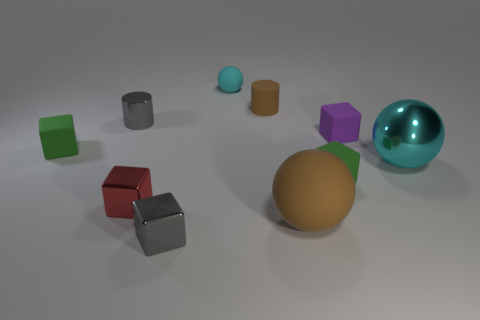How many objects are either spheres on the left side of the small brown rubber thing or big purple shiny cubes?
Your response must be concise. 1. Is the tiny rubber sphere the same color as the shiny ball?
Offer a terse response. Yes. How big is the cyan object that is in front of the small rubber ball?
Offer a very short reply. Large. Is there a gray matte sphere that has the same size as the cyan metal ball?
Your answer should be compact. No. Is the size of the green thing that is on the left side of the gray cylinder the same as the cyan rubber sphere?
Your answer should be very brief. Yes. The cyan shiny object has what size?
Your answer should be very brief. Large. The block that is behind the small green rubber cube behind the thing that is to the right of the purple cube is what color?
Make the answer very short. Purple. There is a small cylinder that is on the left side of the small gray metallic block; is it the same color as the big metallic object?
Offer a terse response. No. What number of metallic things are to the left of the small cyan thing and behind the small gray metallic block?
Make the answer very short. 2. There is a brown thing that is the same shape as the cyan metal object; what is its size?
Ensure brevity in your answer.  Large. 